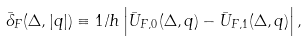Convert formula to latex. <formula><loc_0><loc_0><loc_500><loc_500>\bar { \delta } _ { F } ( \Delta , | q | ) \equiv 1 / h \left | \bar { U } _ { F , 0 } ( \Delta , q ) - \bar { U } _ { F , 1 } ( \Delta , q ) \right | ,</formula> 